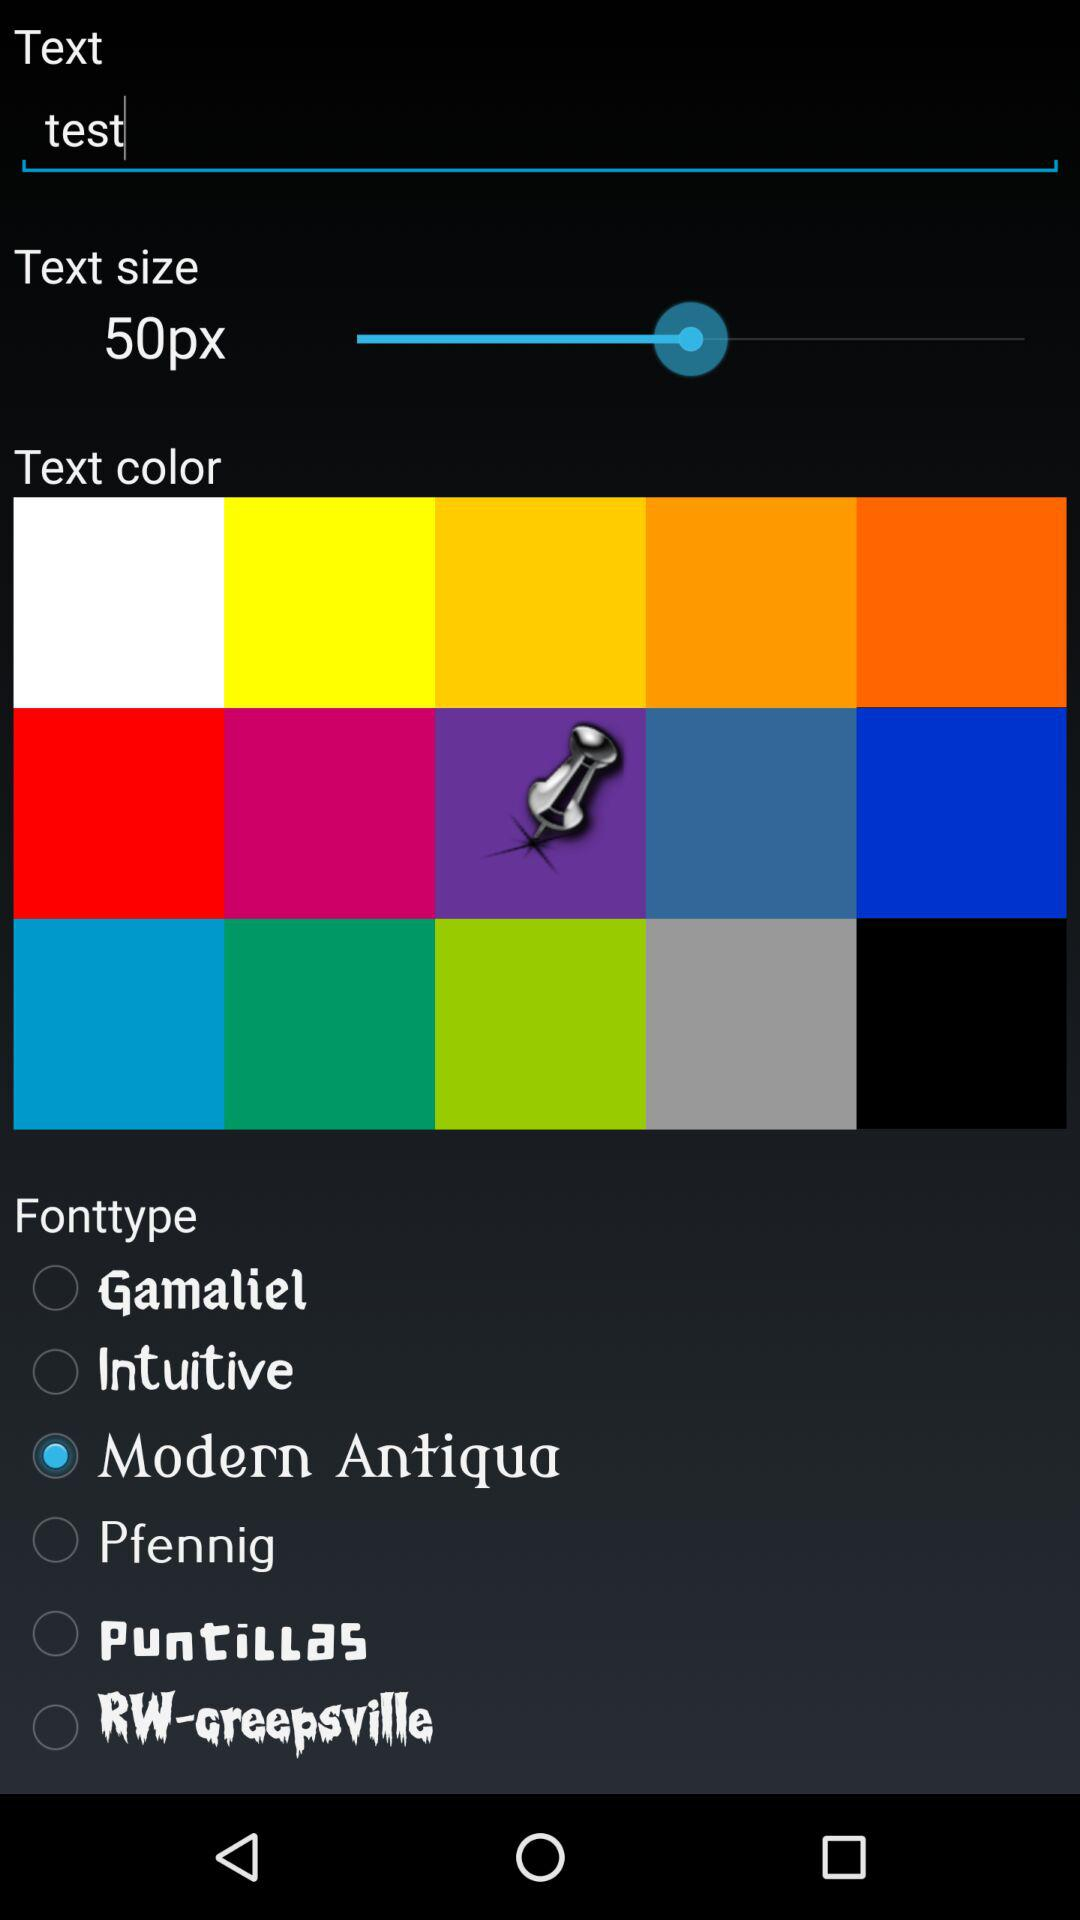What is the selected font type? The selected font type is "Modern Antiqua". 